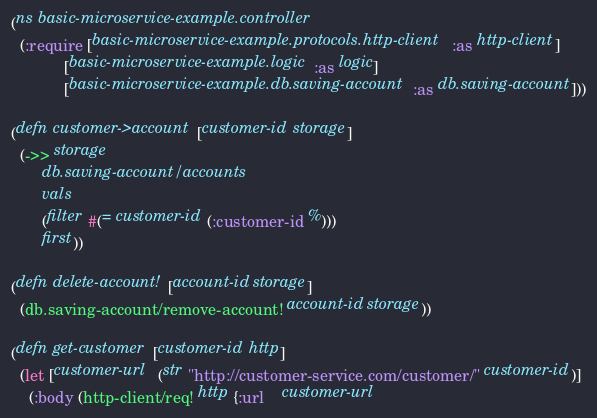Convert code to text. <code><loc_0><loc_0><loc_500><loc_500><_Clojure_>(ns basic-microservice-example.controller
  (:require [basic-microservice-example.protocols.http-client :as http-client]
            [basic-microservice-example.logic :as logic]
            [basic-microservice-example.db.saving-account :as db.saving-account]))

(defn customer->account [customer-id storage]
  (->> storage
       db.saving-account/accounts
       vals
       (filter #(= customer-id (:customer-id %)))
       first))

(defn delete-account! [account-id storage]
  (db.saving-account/remove-account! account-id storage))

(defn get-customer [customer-id http]
  (let [customer-url  (str "http://customer-service.com/customer/" customer-id)]
    (:body (http-client/req! http {:url    customer-url</code> 